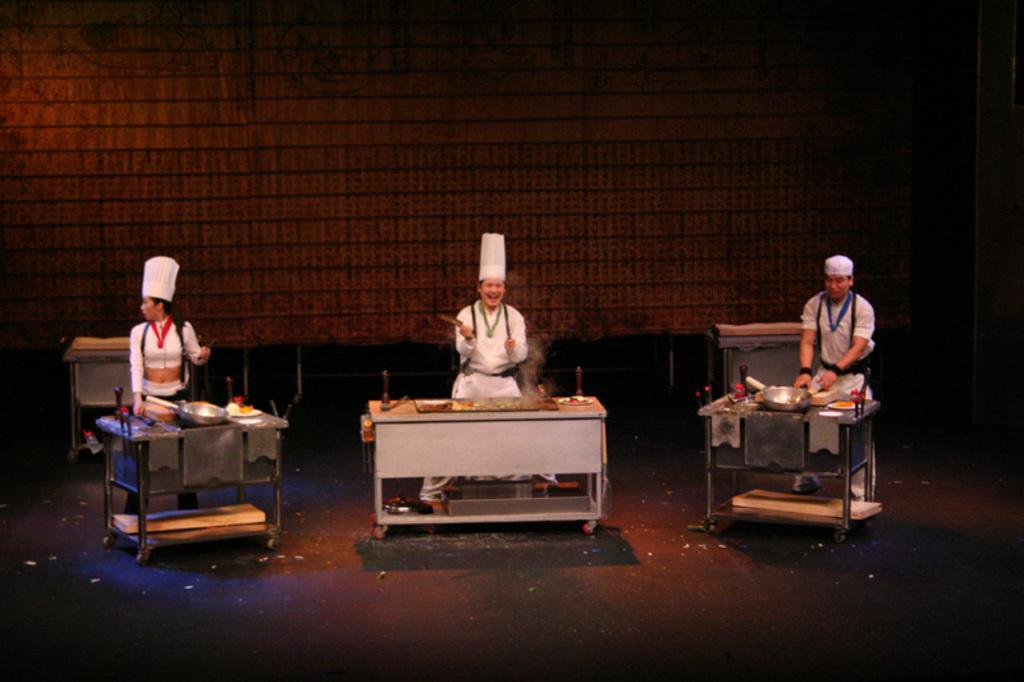Could you give a brief overview of what you see in this image? In this image I can see three persons standing and they are wearing white color dresses. In front I can see few utensils and few tables and I can see the brown color background. 